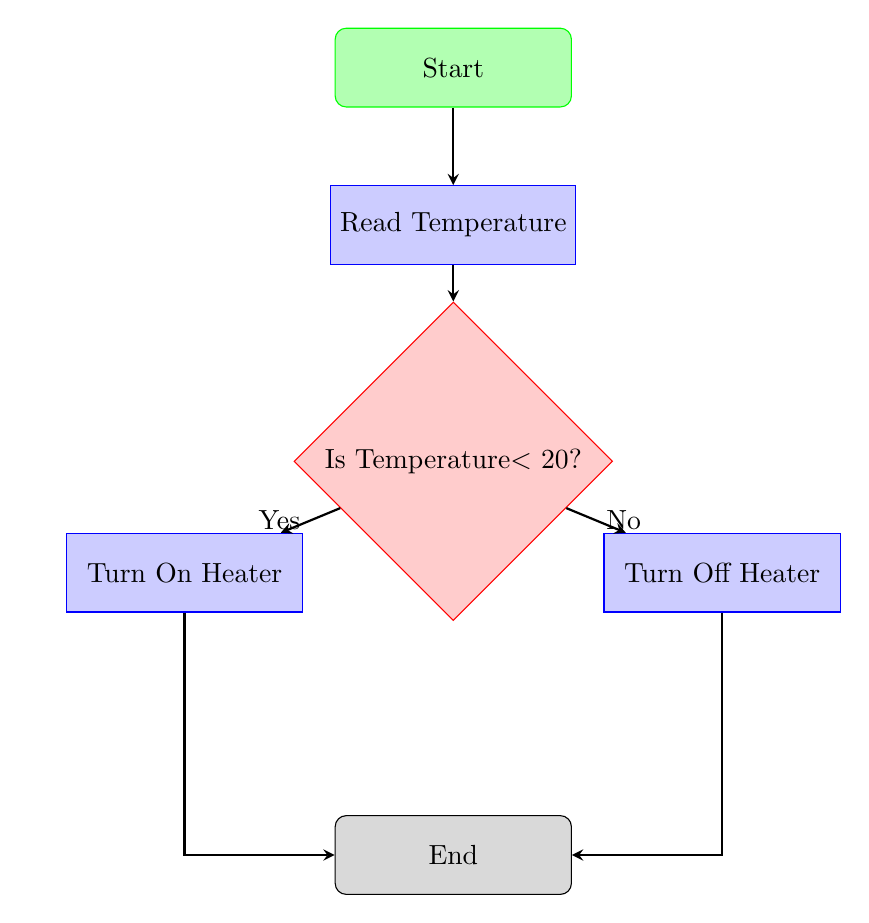What is the first node in the flowchart? The first node in the flowchart is labeled "Start". This can be identified as it has no incoming edges and is positioned at the top of the flowchart.
Answer: Start What action occurs after reading the temperature? After reading the temperature, the next action is a decision node labeled "Is Temperature < 20?". This can be confirmed by following the edge leading down from the "Read Temperature" node.
Answer: Is Temperature < 20? How many process nodes are there in the flowchart? There are two process nodes in the flowchart: "Turn On Heater" and "Turn Off Heater". This is determined by counting the rectangles defining processes in the diagram.
Answer: 2 What happens if the temperature is less than 20? If the temperature is less than 20, the flowchart directs to the process node labeled "Turn On Heater". This is indicated by the edge from the decision node when the answer is "Yes".
Answer: Turn On Heater What is the final action before the flowchart ends? The final action before the flowchart ends is represented by the node "Turn Off Heater", as indicated by the "No" path from the decision node that leads to it before leading to the "End".
Answer: Turn Off Heater What type of node is "Is Temperature < 20?" The node "Is Temperature < 20?" is a decision node. Decision nodes are represented as diamonds in flowcharts, distinguishing them from other types like processes or start/end nodes.
Answer: decision How does the diagram conclude? The diagram concludes with the node labeled "End". This is the last node in the flowchart and can be reached from both process nodes.
Answer: End Which process node is connected to the "Yes" label? The process node connected to the "Yes" label is "Turn On Heater". This can be verified by following the edge from the decision node labeled "Is Temperature < 20?".
Answer: Turn On Heater What is the relationship between the "Read Temperature" node and the "End" node? The relationship is that the "Read Temperature" node leads to the decision, which ultimately leads to either of the process nodes, both of which eventually connect to the "End" node. This shows a dependency between these actions before reaching completion.
Answer: indirect via decisions and actions 